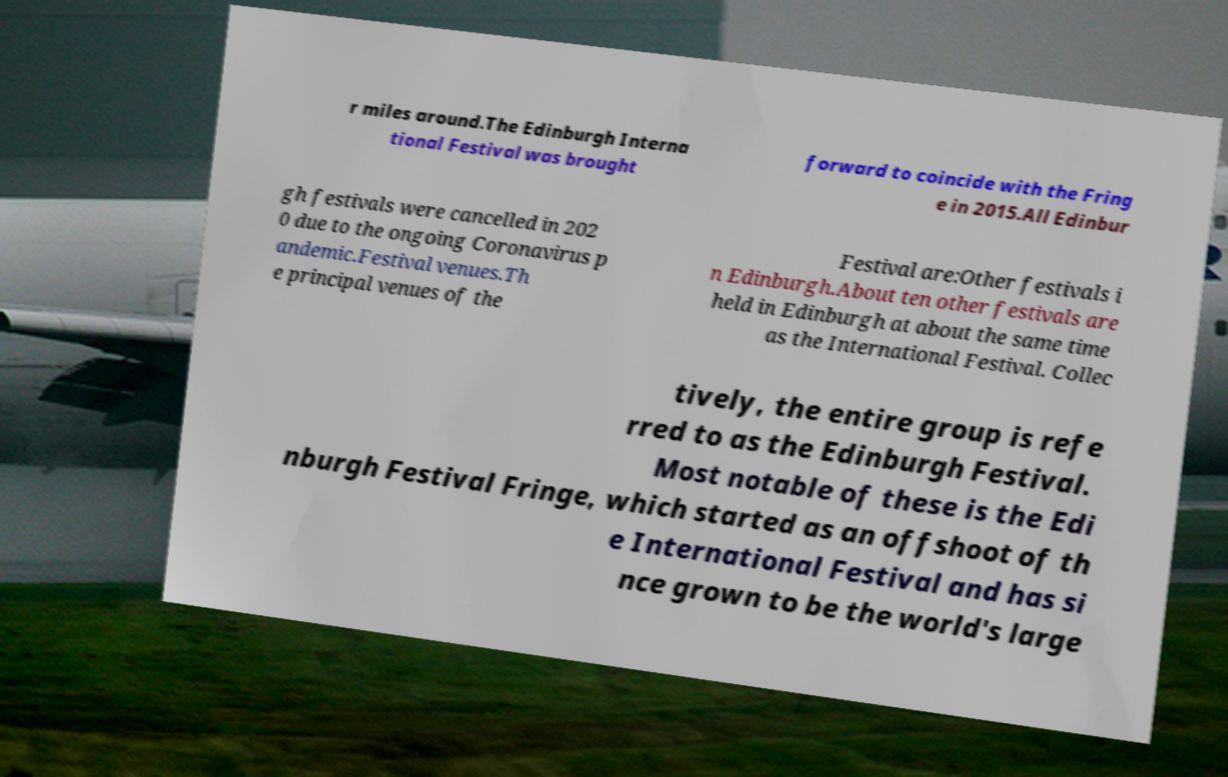Please read and relay the text visible in this image. What does it say? r miles around.The Edinburgh Interna tional Festival was brought forward to coincide with the Fring e in 2015.All Edinbur gh festivals were cancelled in 202 0 due to the ongoing Coronavirus p andemic.Festival venues.Th e principal venues of the Festival are:Other festivals i n Edinburgh.About ten other festivals are held in Edinburgh at about the same time as the International Festival. Collec tively, the entire group is refe rred to as the Edinburgh Festival. Most notable of these is the Edi nburgh Festival Fringe, which started as an offshoot of th e International Festival and has si nce grown to be the world's large 